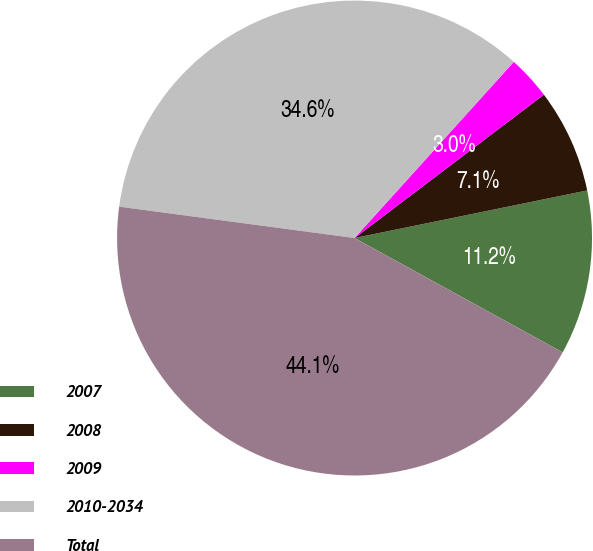Convert chart to OTSL. <chart><loc_0><loc_0><loc_500><loc_500><pie_chart><fcel>2007<fcel>2008<fcel>2009<fcel>2010-2034<fcel>Total<nl><fcel>11.21%<fcel>7.1%<fcel>2.99%<fcel>34.59%<fcel>44.11%<nl></chart> 